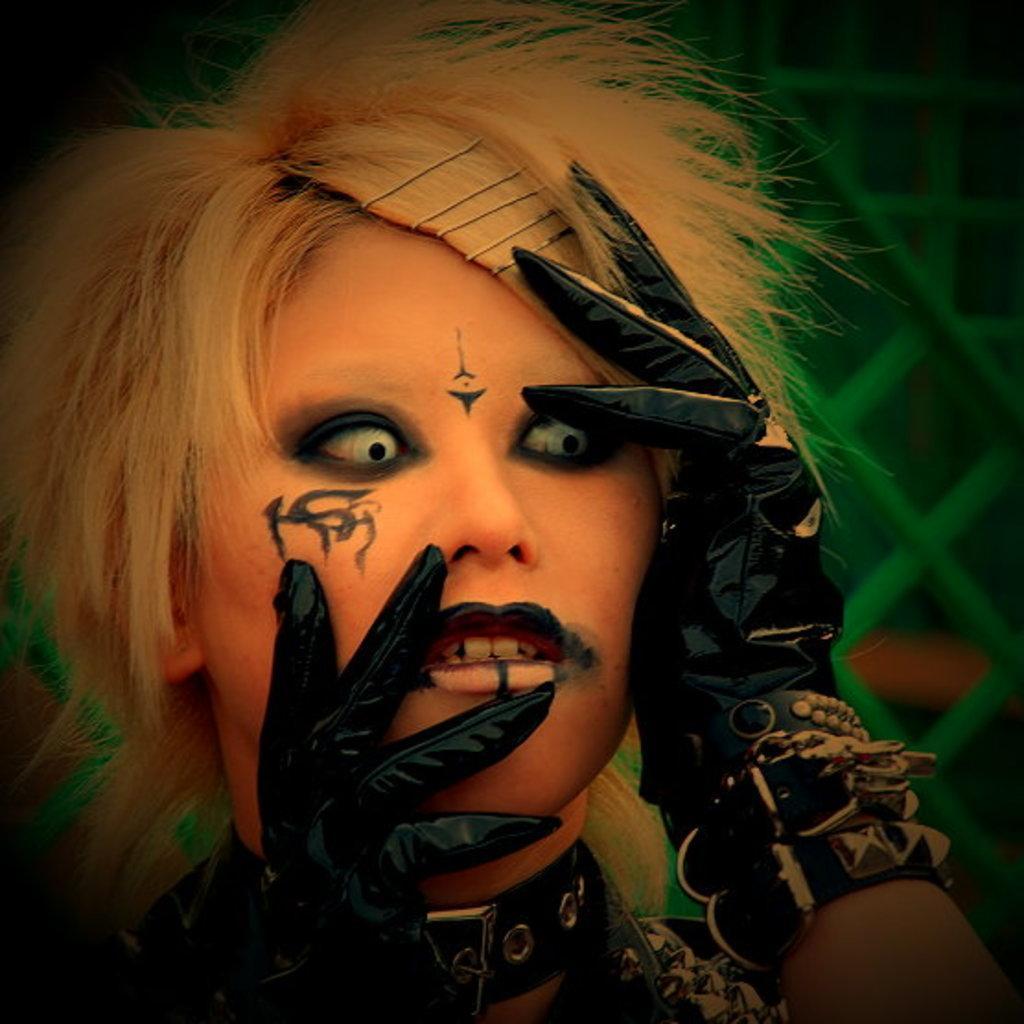How would you summarize this image in a sentence or two? In this image we can see a woman wearing gloves, hairpins and a neck belt. 